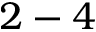<formula> <loc_0><loc_0><loc_500><loc_500>2 - 4</formula> 